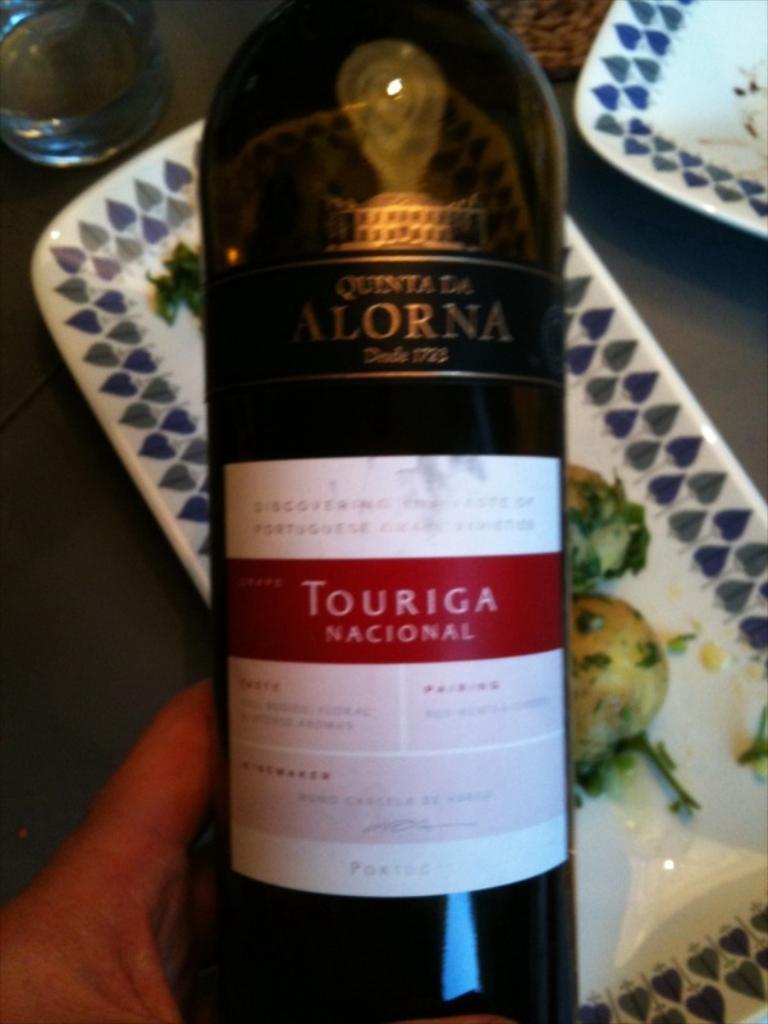Describe this image in one or two sentences. In this image, we can see a human hand with bottle. There is a sticker on it. Background we can see two trays and glasses on the surface. Here there is a food on the tray. 